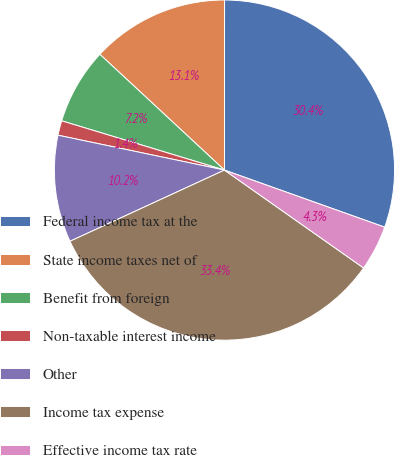Convert chart. <chart><loc_0><loc_0><loc_500><loc_500><pie_chart><fcel>Federal income tax at the<fcel>State income taxes net of<fcel>Benefit from foreign<fcel>Non-taxable interest income<fcel>Other<fcel>Income tax expense<fcel>Effective income tax rate<nl><fcel>30.44%<fcel>13.09%<fcel>7.24%<fcel>1.39%<fcel>10.16%<fcel>33.37%<fcel>4.31%<nl></chart> 